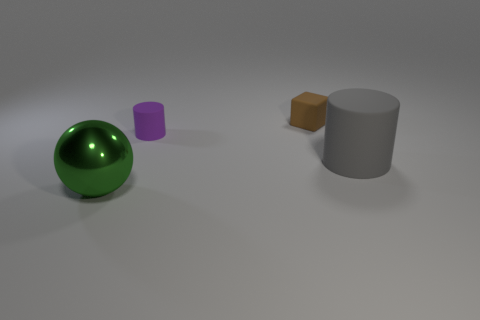Are there any other things that have the same material as the green sphere?
Give a very brief answer. No. How many small things are either brown cubes or green spheres?
Provide a succinct answer. 1. Are there the same number of green balls to the right of the big gray thing and cubes?
Your response must be concise. No. Are there any green shiny objects that are behind the big object that is behind the big green sphere?
Your response must be concise. No. What number of other objects are the same color as the small block?
Offer a very short reply. 0. What color is the block?
Give a very brief answer. Brown. How big is the matte thing that is to the left of the large rubber cylinder and in front of the tiny block?
Give a very brief answer. Small. What number of things are either cylinders that are on the left side of the gray cylinder or balls?
Make the answer very short. 2. What shape is the tiny purple thing that is the same material as the gray thing?
Provide a short and direct response. Cylinder. The brown matte thing is what shape?
Offer a terse response. Cube. 